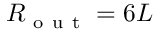Convert formula to latex. <formula><loc_0><loc_0><loc_500><loc_500>R _ { o u t } = 6 L</formula> 